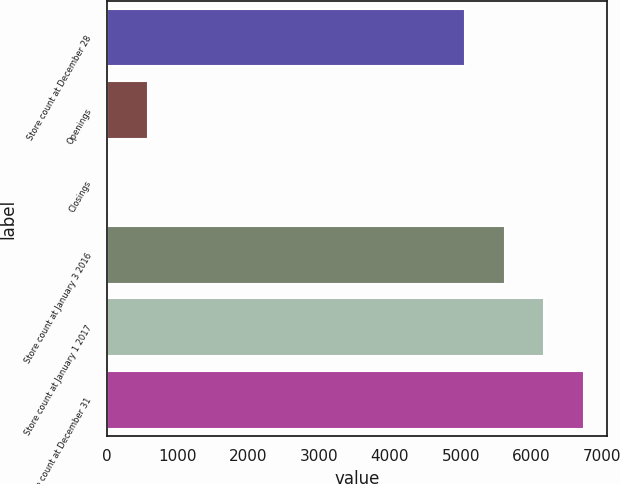<chart> <loc_0><loc_0><loc_500><loc_500><bar_chart><fcel>Store count at December 28<fcel>Openings<fcel>Closings<fcel>Store count at January 3 2016<fcel>Store count at January 1 2017<fcel>Store count at December 31<nl><fcel>5067<fcel>583<fcel>27<fcel>5623<fcel>6179<fcel>6735<nl></chart> 